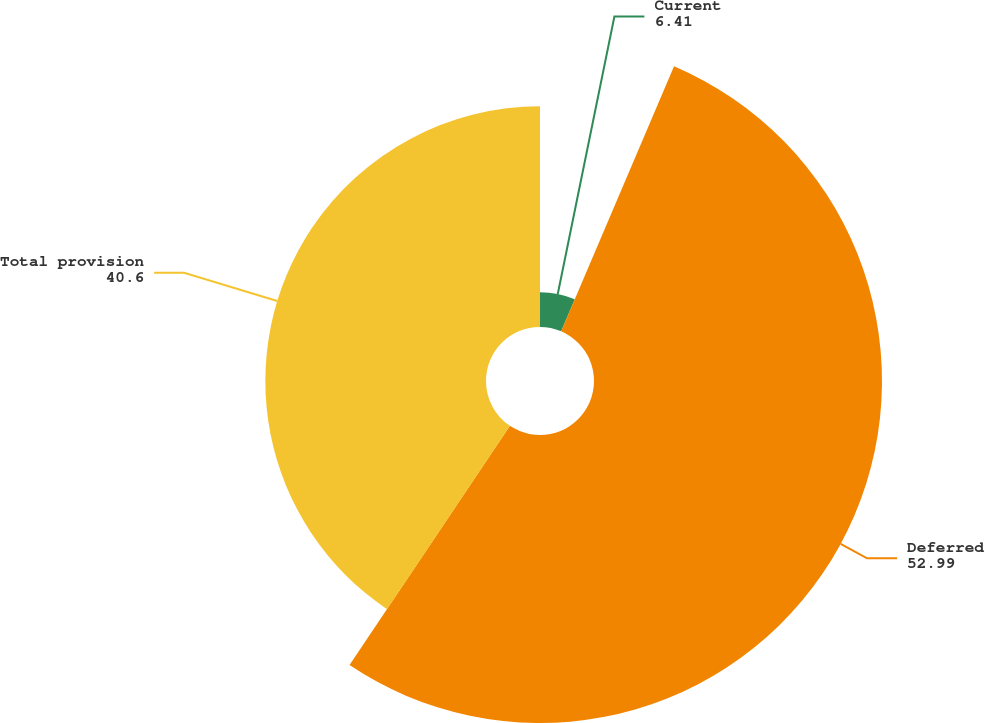Convert chart to OTSL. <chart><loc_0><loc_0><loc_500><loc_500><pie_chart><fcel>Current<fcel>Deferred<fcel>Total provision<nl><fcel>6.41%<fcel>52.99%<fcel>40.6%<nl></chart> 